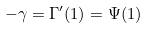<formula> <loc_0><loc_0><loc_500><loc_500>- \gamma = \Gamma ^ { \prime } ( 1 ) = \Psi ( 1 )</formula> 